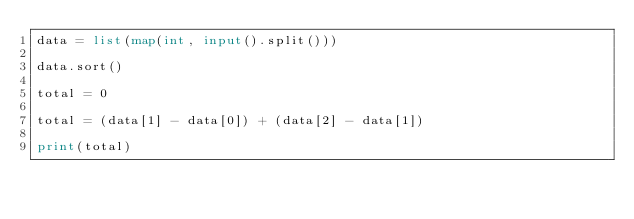<code> <loc_0><loc_0><loc_500><loc_500><_Python_>data = list(map(int, input().split()))

data.sort()

total = 0

total = (data[1] - data[0]) + (data[2] - data[1])

print(total)</code> 